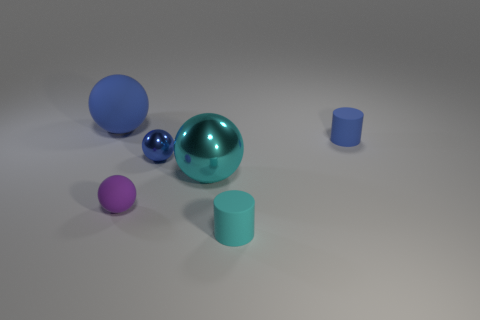Are there fewer large objects that are behind the blue cylinder than cyan matte things?
Offer a terse response. No. What number of other cyan balls are the same size as the cyan ball?
Ensure brevity in your answer.  0. There is a matte object that is the same color as the big metal ball; what is its shape?
Make the answer very short. Cylinder. There is a blue rubber object that is behind the blue matte object that is on the right side of the small blue thing to the left of the big cyan thing; what is its shape?
Make the answer very short. Sphere. What is the color of the shiny ball behind the cyan sphere?
Offer a very short reply. Blue. How many objects are either blue objects on the left side of the tiny blue matte object or blue rubber objects that are left of the purple matte thing?
Provide a short and direct response. 2. How many large matte objects are the same shape as the small cyan matte thing?
Offer a terse response. 0. What color is the other metallic object that is the same size as the purple thing?
Make the answer very short. Blue. There is a matte cylinder that is behind the small cylinder in front of the big ball right of the large rubber thing; what is its color?
Offer a very short reply. Blue. There is a blue matte ball; is its size the same as the cylinder in front of the tiny blue rubber object?
Your response must be concise. No. 